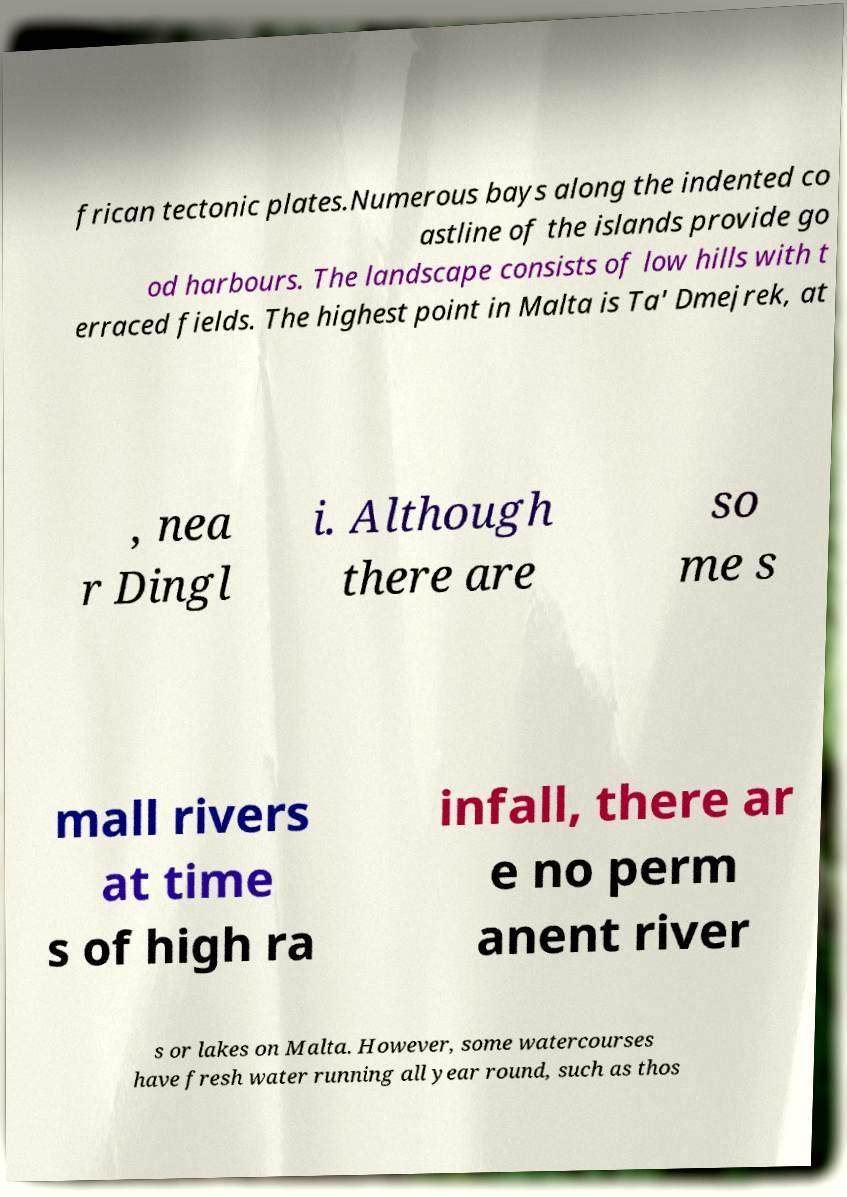Could you extract and type out the text from this image? frican tectonic plates.Numerous bays along the indented co astline of the islands provide go od harbours. The landscape consists of low hills with t erraced fields. The highest point in Malta is Ta' Dmejrek, at , nea r Dingl i. Although there are so me s mall rivers at time s of high ra infall, there ar e no perm anent river s or lakes on Malta. However, some watercourses have fresh water running all year round, such as thos 